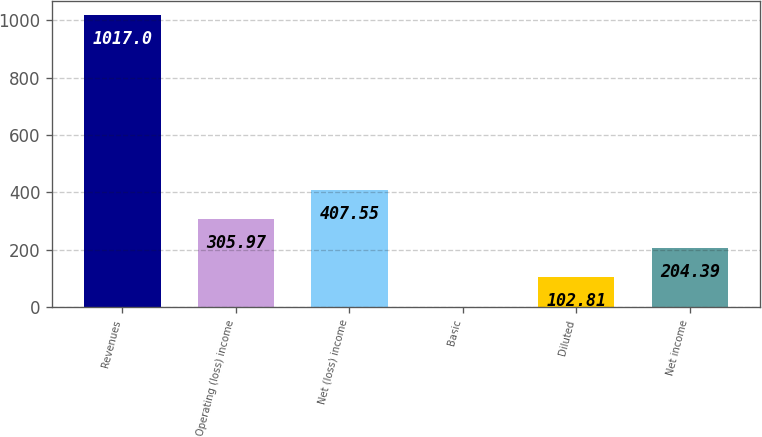Convert chart to OTSL. <chart><loc_0><loc_0><loc_500><loc_500><bar_chart><fcel>Revenues<fcel>Operating (loss) income<fcel>Net (loss) income<fcel>Basic<fcel>Diluted<fcel>Net income<nl><fcel>1017<fcel>305.97<fcel>407.55<fcel>1.23<fcel>102.81<fcel>204.39<nl></chart> 